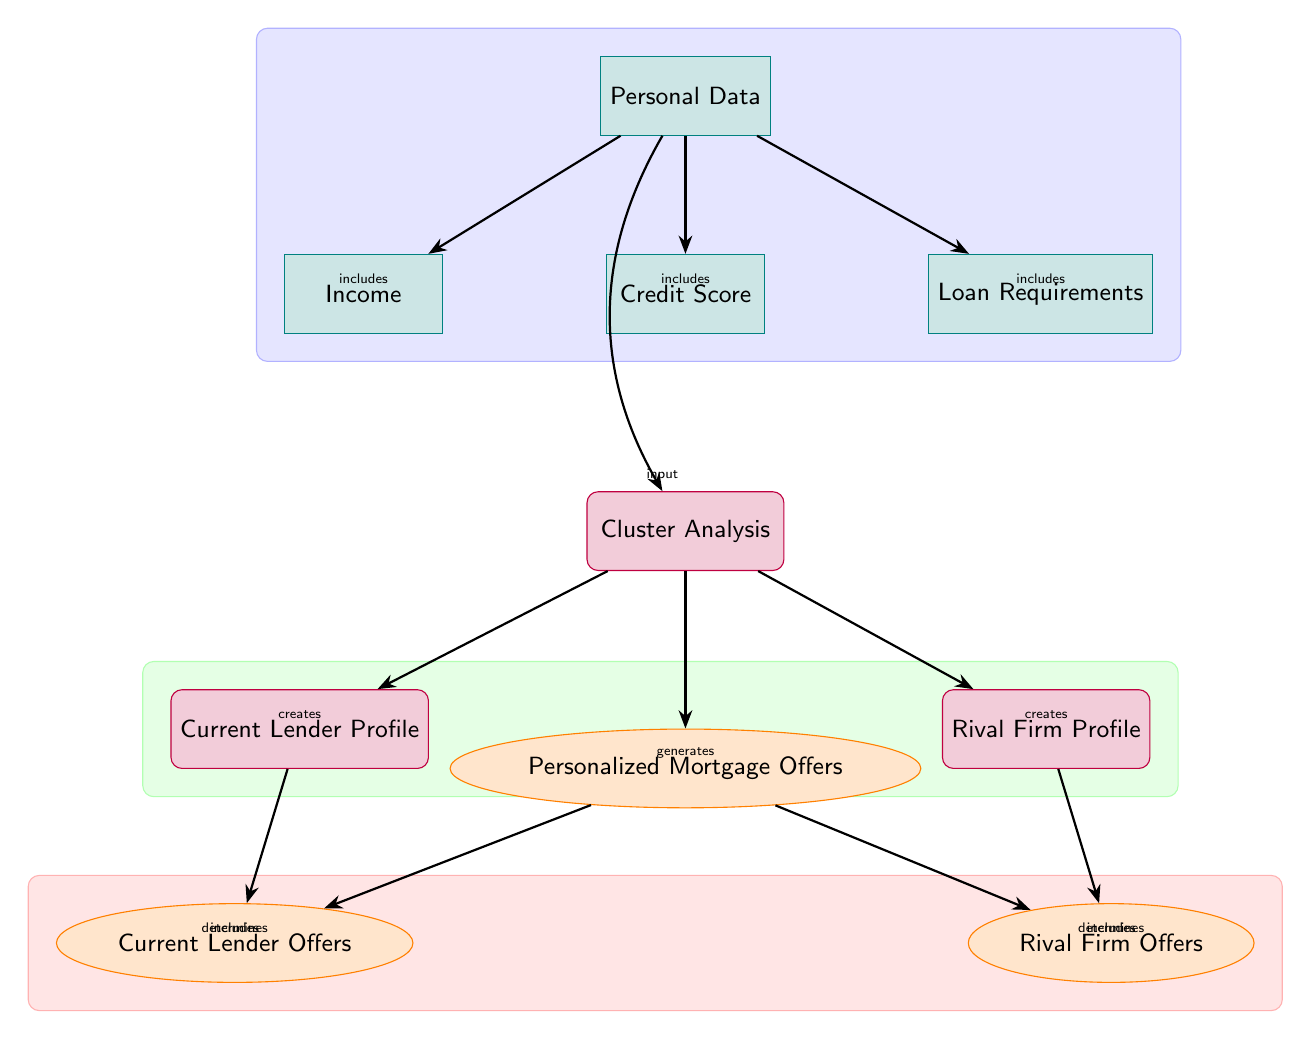What are the three types of personal data considered? The diagram indicates three types of personal data inputs: Income, Credit Score, and Loan Requirements, which are all categorized under the "Personal Data" node.
Answer: Income, Credit Score, Loan Requirements How many output nodes are there in the diagram? The diagram clearly shows two output nodes: Current Lender Offers and Rival Firm Offers, both derived from the Personalized Mortgage Offers node.
Answer: 2 What does the "Cluster Analysis" process create? The diagram states that the Cluster Analysis process not only creates the Current Lender Profile but also the Rival Firm Profile, linking these two outputs directly to the analysis.
Answer: Current Lender Profile, Rival Firm Profile Which node directly influences the Current Lender Offers? The node that directly influences the Current Lender Offers is the Current Lender Profile, as indicated by the arrow leading from this process to the output node.
Answer: Current Lender Profile What serves as the input for the Cluster Analysis? The input for the Cluster Analysis is derived from the Personal Data node, which encompasses income, credit score, and loan requirements. This input feeds into the cluster analysis process, as shown in the diagram.
Answer: Personal Data How many total edges are there in the diagram? To find the total edges, we count all the arrows connecting nodes. The diagram contains eight edges, linking all relevant nodes.
Answer: 8 Which output node is connected to the Rival Firm Profile? The Rival Firm Profile is connected to the Rival Firm Offers node, as shown by the arrow going from the Rival Firm Profile to this output node.
Answer: Rival Firm Offers What type of analysis is performed on the personal data? The diagram specifically states that "Cluster Analysis" is performed on the personal data to group customer profiles and tailor offers accordingly.
Answer: Cluster Analysis 